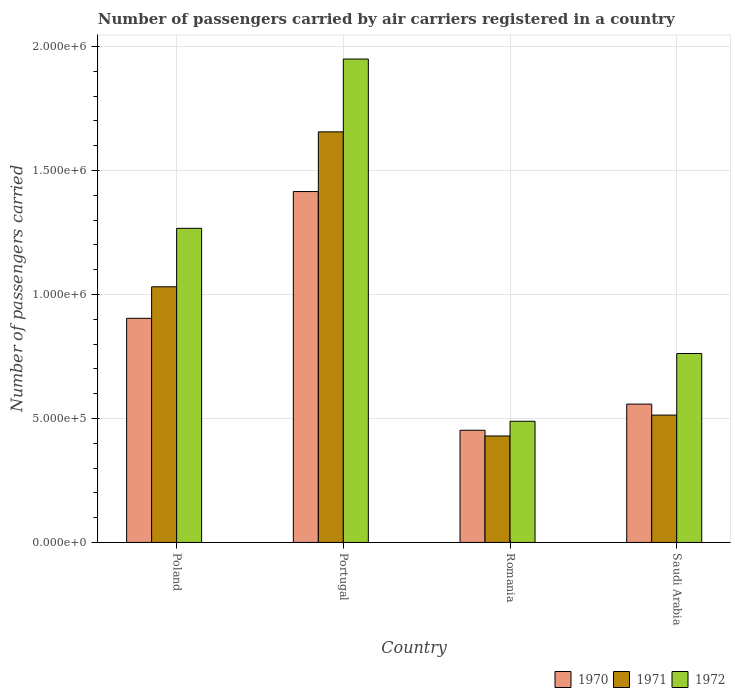How many groups of bars are there?
Your response must be concise. 4. How many bars are there on the 3rd tick from the left?
Your answer should be compact. 3. In how many cases, is the number of bars for a given country not equal to the number of legend labels?
Your response must be concise. 0. What is the number of passengers carried by air carriers in 1971 in Portugal?
Provide a succinct answer. 1.66e+06. Across all countries, what is the maximum number of passengers carried by air carriers in 1970?
Offer a very short reply. 1.42e+06. Across all countries, what is the minimum number of passengers carried by air carriers in 1972?
Give a very brief answer. 4.89e+05. In which country was the number of passengers carried by air carriers in 1972 minimum?
Ensure brevity in your answer.  Romania. What is the total number of passengers carried by air carriers in 1971 in the graph?
Your answer should be very brief. 3.63e+06. What is the difference between the number of passengers carried by air carriers in 1972 in Portugal and that in Romania?
Offer a terse response. 1.46e+06. What is the difference between the number of passengers carried by air carriers in 1972 in Poland and the number of passengers carried by air carriers in 1971 in Saudi Arabia?
Offer a terse response. 7.53e+05. What is the average number of passengers carried by air carriers in 1971 per country?
Your response must be concise. 9.08e+05. What is the difference between the number of passengers carried by air carriers of/in 1971 and number of passengers carried by air carriers of/in 1970 in Poland?
Give a very brief answer. 1.27e+05. In how many countries, is the number of passengers carried by air carriers in 1970 greater than 1200000?
Provide a succinct answer. 1. What is the ratio of the number of passengers carried by air carriers in 1972 in Romania to that in Saudi Arabia?
Offer a terse response. 0.64. Is the number of passengers carried by air carriers in 1972 in Portugal less than that in Saudi Arabia?
Offer a terse response. No. What is the difference between the highest and the second highest number of passengers carried by air carriers in 1970?
Provide a short and direct response. 5.11e+05. What is the difference between the highest and the lowest number of passengers carried by air carriers in 1970?
Offer a very short reply. 9.63e+05. What does the 1st bar from the left in Poland represents?
Ensure brevity in your answer.  1970. What does the 3rd bar from the right in Poland represents?
Offer a very short reply. 1970. Is it the case that in every country, the sum of the number of passengers carried by air carriers in 1970 and number of passengers carried by air carriers in 1972 is greater than the number of passengers carried by air carriers in 1971?
Offer a very short reply. Yes. How many bars are there?
Offer a terse response. 12. Are all the bars in the graph horizontal?
Ensure brevity in your answer.  No. Are the values on the major ticks of Y-axis written in scientific E-notation?
Provide a short and direct response. Yes. Does the graph contain any zero values?
Give a very brief answer. No. Where does the legend appear in the graph?
Ensure brevity in your answer.  Bottom right. How many legend labels are there?
Give a very brief answer. 3. How are the legend labels stacked?
Your answer should be very brief. Horizontal. What is the title of the graph?
Keep it short and to the point. Number of passengers carried by air carriers registered in a country. Does "1975" appear as one of the legend labels in the graph?
Give a very brief answer. No. What is the label or title of the X-axis?
Your answer should be compact. Country. What is the label or title of the Y-axis?
Keep it short and to the point. Number of passengers carried. What is the Number of passengers carried in 1970 in Poland?
Offer a very short reply. 9.04e+05. What is the Number of passengers carried of 1971 in Poland?
Your answer should be compact. 1.03e+06. What is the Number of passengers carried in 1972 in Poland?
Ensure brevity in your answer.  1.27e+06. What is the Number of passengers carried of 1970 in Portugal?
Provide a succinct answer. 1.42e+06. What is the Number of passengers carried in 1971 in Portugal?
Ensure brevity in your answer.  1.66e+06. What is the Number of passengers carried of 1972 in Portugal?
Offer a terse response. 1.95e+06. What is the Number of passengers carried of 1970 in Romania?
Make the answer very short. 4.52e+05. What is the Number of passengers carried of 1971 in Romania?
Make the answer very short. 4.29e+05. What is the Number of passengers carried of 1972 in Romania?
Your response must be concise. 4.89e+05. What is the Number of passengers carried in 1970 in Saudi Arabia?
Offer a very short reply. 5.58e+05. What is the Number of passengers carried in 1971 in Saudi Arabia?
Make the answer very short. 5.14e+05. What is the Number of passengers carried of 1972 in Saudi Arabia?
Offer a terse response. 7.62e+05. Across all countries, what is the maximum Number of passengers carried in 1970?
Provide a succinct answer. 1.42e+06. Across all countries, what is the maximum Number of passengers carried in 1971?
Give a very brief answer. 1.66e+06. Across all countries, what is the maximum Number of passengers carried of 1972?
Give a very brief answer. 1.95e+06. Across all countries, what is the minimum Number of passengers carried in 1970?
Your answer should be compact. 4.52e+05. Across all countries, what is the minimum Number of passengers carried of 1971?
Provide a short and direct response. 4.29e+05. Across all countries, what is the minimum Number of passengers carried in 1972?
Make the answer very short. 4.89e+05. What is the total Number of passengers carried in 1970 in the graph?
Your response must be concise. 3.33e+06. What is the total Number of passengers carried of 1971 in the graph?
Keep it short and to the point. 3.63e+06. What is the total Number of passengers carried in 1972 in the graph?
Provide a short and direct response. 4.47e+06. What is the difference between the Number of passengers carried of 1970 in Poland and that in Portugal?
Make the answer very short. -5.11e+05. What is the difference between the Number of passengers carried of 1971 in Poland and that in Portugal?
Offer a terse response. -6.25e+05. What is the difference between the Number of passengers carried of 1972 in Poland and that in Portugal?
Offer a very short reply. -6.83e+05. What is the difference between the Number of passengers carried in 1970 in Poland and that in Romania?
Make the answer very short. 4.52e+05. What is the difference between the Number of passengers carried of 1971 in Poland and that in Romania?
Your response must be concise. 6.02e+05. What is the difference between the Number of passengers carried of 1972 in Poland and that in Romania?
Provide a succinct answer. 7.78e+05. What is the difference between the Number of passengers carried in 1970 in Poland and that in Saudi Arabia?
Offer a terse response. 3.46e+05. What is the difference between the Number of passengers carried of 1971 in Poland and that in Saudi Arabia?
Offer a terse response. 5.18e+05. What is the difference between the Number of passengers carried in 1972 in Poland and that in Saudi Arabia?
Your response must be concise. 5.05e+05. What is the difference between the Number of passengers carried in 1970 in Portugal and that in Romania?
Your answer should be compact. 9.63e+05. What is the difference between the Number of passengers carried of 1971 in Portugal and that in Romania?
Keep it short and to the point. 1.23e+06. What is the difference between the Number of passengers carried in 1972 in Portugal and that in Romania?
Ensure brevity in your answer.  1.46e+06. What is the difference between the Number of passengers carried in 1970 in Portugal and that in Saudi Arabia?
Offer a terse response. 8.57e+05. What is the difference between the Number of passengers carried in 1971 in Portugal and that in Saudi Arabia?
Give a very brief answer. 1.14e+06. What is the difference between the Number of passengers carried in 1972 in Portugal and that in Saudi Arabia?
Provide a short and direct response. 1.19e+06. What is the difference between the Number of passengers carried in 1970 in Romania and that in Saudi Arabia?
Ensure brevity in your answer.  -1.06e+05. What is the difference between the Number of passengers carried of 1971 in Romania and that in Saudi Arabia?
Your answer should be very brief. -8.42e+04. What is the difference between the Number of passengers carried of 1972 in Romania and that in Saudi Arabia?
Your response must be concise. -2.73e+05. What is the difference between the Number of passengers carried of 1970 in Poland and the Number of passengers carried of 1971 in Portugal?
Ensure brevity in your answer.  -7.52e+05. What is the difference between the Number of passengers carried in 1970 in Poland and the Number of passengers carried in 1972 in Portugal?
Offer a very short reply. -1.05e+06. What is the difference between the Number of passengers carried in 1971 in Poland and the Number of passengers carried in 1972 in Portugal?
Your response must be concise. -9.19e+05. What is the difference between the Number of passengers carried of 1970 in Poland and the Number of passengers carried of 1971 in Romania?
Provide a short and direct response. 4.75e+05. What is the difference between the Number of passengers carried of 1970 in Poland and the Number of passengers carried of 1972 in Romania?
Make the answer very short. 4.15e+05. What is the difference between the Number of passengers carried of 1971 in Poland and the Number of passengers carried of 1972 in Romania?
Keep it short and to the point. 5.42e+05. What is the difference between the Number of passengers carried in 1970 in Poland and the Number of passengers carried in 1971 in Saudi Arabia?
Offer a terse response. 3.90e+05. What is the difference between the Number of passengers carried of 1970 in Poland and the Number of passengers carried of 1972 in Saudi Arabia?
Your answer should be very brief. 1.42e+05. What is the difference between the Number of passengers carried in 1971 in Poland and the Number of passengers carried in 1972 in Saudi Arabia?
Provide a short and direct response. 2.69e+05. What is the difference between the Number of passengers carried of 1970 in Portugal and the Number of passengers carried of 1971 in Romania?
Give a very brief answer. 9.86e+05. What is the difference between the Number of passengers carried of 1970 in Portugal and the Number of passengers carried of 1972 in Romania?
Offer a terse response. 9.27e+05. What is the difference between the Number of passengers carried of 1971 in Portugal and the Number of passengers carried of 1972 in Romania?
Offer a very short reply. 1.17e+06. What is the difference between the Number of passengers carried of 1970 in Portugal and the Number of passengers carried of 1971 in Saudi Arabia?
Keep it short and to the point. 9.02e+05. What is the difference between the Number of passengers carried in 1970 in Portugal and the Number of passengers carried in 1972 in Saudi Arabia?
Ensure brevity in your answer.  6.53e+05. What is the difference between the Number of passengers carried in 1971 in Portugal and the Number of passengers carried in 1972 in Saudi Arabia?
Ensure brevity in your answer.  8.94e+05. What is the difference between the Number of passengers carried of 1970 in Romania and the Number of passengers carried of 1971 in Saudi Arabia?
Offer a terse response. -6.11e+04. What is the difference between the Number of passengers carried in 1970 in Romania and the Number of passengers carried in 1972 in Saudi Arabia?
Ensure brevity in your answer.  -3.10e+05. What is the difference between the Number of passengers carried in 1971 in Romania and the Number of passengers carried in 1972 in Saudi Arabia?
Your response must be concise. -3.33e+05. What is the average Number of passengers carried of 1970 per country?
Offer a terse response. 8.32e+05. What is the average Number of passengers carried in 1971 per country?
Give a very brief answer. 9.08e+05. What is the average Number of passengers carried in 1972 per country?
Provide a succinct answer. 1.12e+06. What is the difference between the Number of passengers carried of 1970 and Number of passengers carried of 1971 in Poland?
Keep it short and to the point. -1.27e+05. What is the difference between the Number of passengers carried of 1970 and Number of passengers carried of 1972 in Poland?
Give a very brief answer. -3.63e+05. What is the difference between the Number of passengers carried in 1971 and Number of passengers carried in 1972 in Poland?
Provide a short and direct response. -2.36e+05. What is the difference between the Number of passengers carried of 1970 and Number of passengers carried of 1971 in Portugal?
Offer a very short reply. -2.41e+05. What is the difference between the Number of passengers carried in 1970 and Number of passengers carried in 1972 in Portugal?
Offer a very short reply. -5.34e+05. What is the difference between the Number of passengers carried in 1971 and Number of passengers carried in 1972 in Portugal?
Your response must be concise. -2.94e+05. What is the difference between the Number of passengers carried in 1970 and Number of passengers carried in 1971 in Romania?
Offer a terse response. 2.31e+04. What is the difference between the Number of passengers carried in 1970 and Number of passengers carried in 1972 in Romania?
Provide a succinct answer. -3.63e+04. What is the difference between the Number of passengers carried of 1971 and Number of passengers carried of 1972 in Romania?
Provide a short and direct response. -5.94e+04. What is the difference between the Number of passengers carried of 1970 and Number of passengers carried of 1971 in Saudi Arabia?
Provide a succinct answer. 4.44e+04. What is the difference between the Number of passengers carried of 1970 and Number of passengers carried of 1972 in Saudi Arabia?
Your answer should be very brief. -2.04e+05. What is the difference between the Number of passengers carried of 1971 and Number of passengers carried of 1972 in Saudi Arabia?
Your response must be concise. -2.48e+05. What is the ratio of the Number of passengers carried in 1970 in Poland to that in Portugal?
Provide a short and direct response. 0.64. What is the ratio of the Number of passengers carried in 1971 in Poland to that in Portugal?
Offer a very short reply. 0.62. What is the ratio of the Number of passengers carried of 1972 in Poland to that in Portugal?
Keep it short and to the point. 0.65. What is the ratio of the Number of passengers carried in 1970 in Poland to that in Romania?
Your answer should be very brief. 2. What is the ratio of the Number of passengers carried in 1971 in Poland to that in Romania?
Offer a very short reply. 2.4. What is the ratio of the Number of passengers carried in 1972 in Poland to that in Romania?
Offer a very short reply. 2.59. What is the ratio of the Number of passengers carried in 1970 in Poland to that in Saudi Arabia?
Offer a terse response. 1.62. What is the ratio of the Number of passengers carried of 1971 in Poland to that in Saudi Arabia?
Offer a very short reply. 2.01. What is the ratio of the Number of passengers carried in 1972 in Poland to that in Saudi Arabia?
Your response must be concise. 1.66. What is the ratio of the Number of passengers carried of 1970 in Portugal to that in Romania?
Offer a very short reply. 3.13. What is the ratio of the Number of passengers carried of 1971 in Portugal to that in Romania?
Ensure brevity in your answer.  3.86. What is the ratio of the Number of passengers carried in 1972 in Portugal to that in Romania?
Keep it short and to the point. 3.99. What is the ratio of the Number of passengers carried in 1970 in Portugal to that in Saudi Arabia?
Offer a terse response. 2.54. What is the ratio of the Number of passengers carried of 1971 in Portugal to that in Saudi Arabia?
Make the answer very short. 3.22. What is the ratio of the Number of passengers carried of 1972 in Portugal to that in Saudi Arabia?
Offer a very short reply. 2.56. What is the ratio of the Number of passengers carried of 1970 in Romania to that in Saudi Arabia?
Provide a succinct answer. 0.81. What is the ratio of the Number of passengers carried of 1971 in Romania to that in Saudi Arabia?
Your answer should be very brief. 0.84. What is the ratio of the Number of passengers carried in 1972 in Romania to that in Saudi Arabia?
Offer a very short reply. 0.64. What is the difference between the highest and the second highest Number of passengers carried of 1970?
Provide a short and direct response. 5.11e+05. What is the difference between the highest and the second highest Number of passengers carried in 1971?
Ensure brevity in your answer.  6.25e+05. What is the difference between the highest and the second highest Number of passengers carried in 1972?
Give a very brief answer. 6.83e+05. What is the difference between the highest and the lowest Number of passengers carried in 1970?
Give a very brief answer. 9.63e+05. What is the difference between the highest and the lowest Number of passengers carried of 1971?
Offer a terse response. 1.23e+06. What is the difference between the highest and the lowest Number of passengers carried in 1972?
Provide a short and direct response. 1.46e+06. 